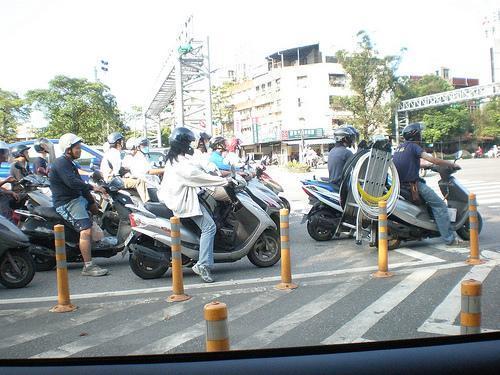How many barrier poles are there?
Give a very brief answer. 7. 